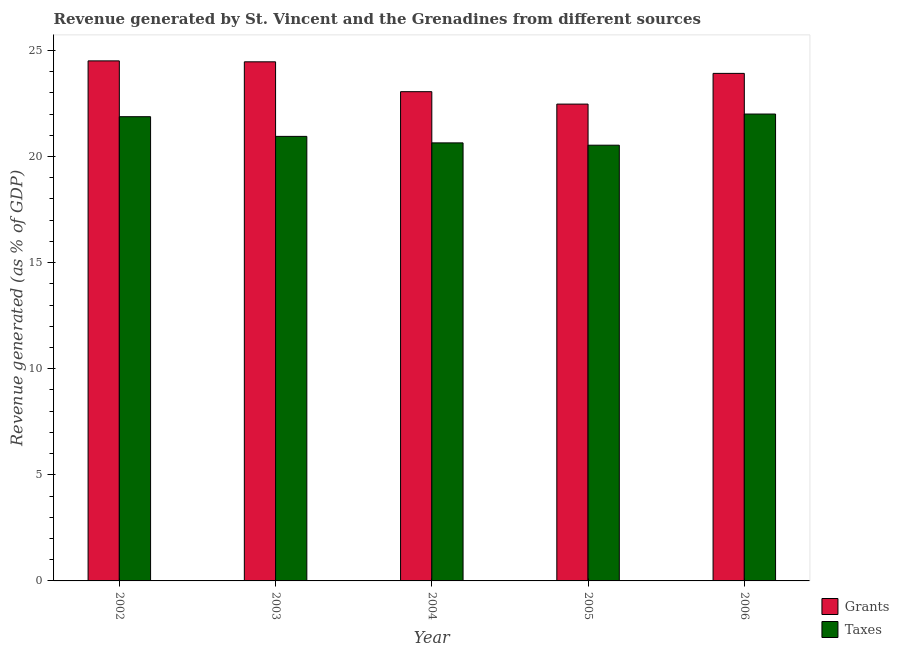How many groups of bars are there?
Provide a short and direct response. 5. What is the label of the 5th group of bars from the left?
Ensure brevity in your answer.  2006. In how many cases, is the number of bars for a given year not equal to the number of legend labels?
Your answer should be very brief. 0. What is the revenue generated by taxes in 2006?
Offer a very short reply. 22. Across all years, what is the maximum revenue generated by taxes?
Give a very brief answer. 22. Across all years, what is the minimum revenue generated by grants?
Offer a terse response. 22.47. In which year was the revenue generated by grants maximum?
Your response must be concise. 2002. What is the total revenue generated by grants in the graph?
Provide a short and direct response. 118.4. What is the difference between the revenue generated by grants in 2002 and that in 2004?
Your response must be concise. 1.45. What is the difference between the revenue generated by taxes in 2003 and the revenue generated by grants in 2005?
Offer a very short reply. 0.42. What is the average revenue generated by taxes per year?
Your answer should be compact. 21.2. In how many years, is the revenue generated by grants greater than 17 %?
Provide a succinct answer. 5. What is the ratio of the revenue generated by taxes in 2005 to that in 2006?
Keep it short and to the point. 0.93. Is the revenue generated by taxes in 2003 less than that in 2005?
Your answer should be very brief. No. What is the difference between the highest and the second highest revenue generated by taxes?
Your answer should be very brief. 0.12. What is the difference between the highest and the lowest revenue generated by grants?
Provide a succinct answer. 2.04. Is the sum of the revenue generated by grants in 2004 and 2005 greater than the maximum revenue generated by taxes across all years?
Offer a terse response. Yes. What does the 2nd bar from the left in 2005 represents?
Provide a succinct answer. Taxes. What does the 1st bar from the right in 2002 represents?
Offer a terse response. Taxes. Are all the bars in the graph horizontal?
Provide a short and direct response. No. What is the difference between two consecutive major ticks on the Y-axis?
Your response must be concise. 5. Are the values on the major ticks of Y-axis written in scientific E-notation?
Provide a short and direct response. No. Does the graph contain any zero values?
Your answer should be very brief. No. Does the graph contain grids?
Give a very brief answer. No. What is the title of the graph?
Your answer should be very brief. Revenue generated by St. Vincent and the Grenadines from different sources. What is the label or title of the X-axis?
Ensure brevity in your answer.  Year. What is the label or title of the Y-axis?
Provide a succinct answer. Revenue generated (as % of GDP). What is the Revenue generated (as % of GDP) of Grants in 2002?
Your answer should be compact. 24.51. What is the Revenue generated (as % of GDP) in Taxes in 2002?
Keep it short and to the point. 21.88. What is the Revenue generated (as % of GDP) of Grants in 2003?
Make the answer very short. 24.46. What is the Revenue generated (as % of GDP) of Taxes in 2003?
Offer a very short reply. 20.95. What is the Revenue generated (as % of GDP) of Grants in 2004?
Provide a succinct answer. 23.05. What is the Revenue generated (as % of GDP) of Taxes in 2004?
Offer a terse response. 20.64. What is the Revenue generated (as % of GDP) in Grants in 2005?
Your answer should be very brief. 22.47. What is the Revenue generated (as % of GDP) of Taxes in 2005?
Your answer should be compact. 20.53. What is the Revenue generated (as % of GDP) in Grants in 2006?
Offer a very short reply. 23.92. What is the Revenue generated (as % of GDP) in Taxes in 2006?
Offer a very short reply. 22. Across all years, what is the maximum Revenue generated (as % of GDP) of Grants?
Give a very brief answer. 24.51. Across all years, what is the maximum Revenue generated (as % of GDP) of Taxes?
Your response must be concise. 22. Across all years, what is the minimum Revenue generated (as % of GDP) of Grants?
Your answer should be very brief. 22.47. Across all years, what is the minimum Revenue generated (as % of GDP) in Taxes?
Your answer should be very brief. 20.53. What is the total Revenue generated (as % of GDP) of Grants in the graph?
Offer a very short reply. 118.4. What is the total Revenue generated (as % of GDP) of Taxes in the graph?
Ensure brevity in your answer.  106. What is the difference between the Revenue generated (as % of GDP) of Grants in 2002 and that in 2003?
Your answer should be compact. 0.04. What is the difference between the Revenue generated (as % of GDP) in Taxes in 2002 and that in 2003?
Give a very brief answer. 0.93. What is the difference between the Revenue generated (as % of GDP) in Grants in 2002 and that in 2004?
Provide a succinct answer. 1.45. What is the difference between the Revenue generated (as % of GDP) of Taxes in 2002 and that in 2004?
Your response must be concise. 1.23. What is the difference between the Revenue generated (as % of GDP) of Grants in 2002 and that in 2005?
Your response must be concise. 2.04. What is the difference between the Revenue generated (as % of GDP) of Taxes in 2002 and that in 2005?
Your answer should be very brief. 1.34. What is the difference between the Revenue generated (as % of GDP) in Grants in 2002 and that in 2006?
Offer a terse response. 0.59. What is the difference between the Revenue generated (as % of GDP) of Taxes in 2002 and that in 2006?
Your response must be concise. -0.12. What is the difference between the Revenue generated (as % of GDP) of Grants in 2003 and that in 2004?
Your response must be concise. 1.41. What is the difference between the Revenue generated (as % of GDP) in Taxes in 2003 and that in 2004?
Offer a terse response. 0.31. What is the difference between the Revenue generated (as % of GDP) of Grants in 2003 and that in 2005?
Your response must be concise. 1.99. What is the difference between the Revenue generated (as % of GDP) in Taxes in 2003 and that in 2005?
Your response must be concise. 0.42. What is the difference between the Revenue generated (as % of GDP) in Grants in 2003 and that in 2006?
Ensure brevity in your answer.  0.54. What is the difference between the Revenue generated (as % of GDP) of Taxes in 2003 and that in 2006?
Make the answer very short. -1.05. What is the difference between the Revenue generated (as % of GDP) in Grants in 2004 and that in 2005?
Your answer should be compact. 0.58. What is the difference between the Revenue generated (as % of GDP) in Taxes in 2004 and that in 2005?
Ensure brevity in your answer.  0.11. What is the difference between the Revenue generated (as % of GDP) in Grants in 2004 and that in 2006?
Offer a terse response. -0.86. What is the difference between the Revenue generated (as % of GDP) in Taxes in 2004 and that in 2006?
Provide a succinct answer. -1.36. What is the difference between the Revenue generated (as % of GDP) of Grants in 2005 and that in 2006?
Your answer should be compact. -1.45. What is the difference between the Revenue generated (as % of GDP) in Taxes in 2005 and that in 2006?
Offer a very short reply. -1.47. What is the difference between the Revenue generated (as % of GDP) in Grants in 2002 and the Revenue generated (as % of GDP) in Taxes in 2003?
Your response must be concise. 3.56. What is the difference between the Revenue generated (as % of GDP) in Grants in 2002 and the Revenue generated (as % of GDP) in Taxes in 2004?
Your answer should be compact. 3.86. What is the difference between the Revenue generated (as % of GDP) of Grants in 2002 and the Revenue generated (as % of GDP) of Taxes in 2005?
Your response must be concise. 3.97. What is the difference between the Revenue generated (as % of GDP) in Grants in 2002 and the Revenue generated (as % of GDP) in Taxes in 2006?
Provide a succinct answer. 2.51. What is the difference between the Revenue generated (as % of GDP) in Grants in 2003 and the Revenue generated (as % of GDP) in Taxes in 2004?
Your answer should be compact. 3.82. What is the difference between the Revenue generated (as % of GDP) in Grants in 2003 and the Revenue generated (as % of GDP) in Taxes in 2005?
Offer a very short reply. 3.93. What is the difference between the Revenue generated (as % of GDP) in Grants in 2003 and the Revenue generated (as % of GDP) in Taxes in 2006?
Provide a succinct answer. 2.46. What is the difference between the Revenue generated (as % of GDP) of Grants in 2004 and the Revenue generated (as % of GDP) of Taxes in 2005?
Provide a short and direct response. 2.52. What is the difference between the Revenue generated (as % of GDP) in Grants in 2004 and the Revenue generated (as % of GDP) in Taxes in 2006?
Give a very brief answer. 1.05. What is the difference between the Revenue generated (as % of GDP) of Grants in 2005 and the Revenue generated (as % of GDP) of Taxes in 2006?
Ensure brevity in your answer.  0.47. What is the average Revenue generated (as % of GDP) in Grants per year?
Provide a short and direct response. 23.68. What is the average Revenue generated (as % of GDP) in Taxes per year?
Give a very brief answer. 21.2. In the year 2002, what is the difference between the Revenue generated (as % of GDP) of Grants and Revenue generated (as % of GDP) of Taxes?
Offer a very short reply. 2.63. In the year 2003, what is the difference between the Revenue generated (as % of GDP) of Grants and Revenue generated (as % of GDP) of Taxes?
Your answer should be compact. 3.51. In the year 2004, what is the difference between the Revenue generated (as % of GDP) of Grants and Revenue generated (as % of GDP) of Taxes?
Your answer should be compact. 2.41. In the year 2005, what is the difference between the Revenue generated (as % of GDP) in Grants and Revenue generated (as % of GDP) in Taxes?
Offer a terse response. 1.94. In the year 2006, what is the difference between the Revenue generated (as % of GDP) in Grants and Revenue generated (as % of GDP) in Taxes?
Your answer should be compact. 1.92. What is the ratio of the Revenue generated (as % of GDP) in Grants in 2002 to that in 2003?
Make the answer very short. 1. What is the ratio of the Revenue generated (as % of GDP) in Taxes in 2002 to that in 2003?
Your response must be concise. 1.04. What is the ratio of the Revenue generated (as % of GDP) of Grants in 2002 to that in 2004?
Offer a terse response. 1.06. What is the ratio of the Revenue generated (as % of GDP) of Taxes in 2002 to that in 2004?
Your answer should be compact. 1.06. What is the ratio of the Revenue generated (as % of GDP) in Grants in 2002 to that in 2005?
Offer a terse response. 1.09. What is the ratio of the Revenue generated (as % of GDP) of Taxes in 2002 to that in 2005?
Provide a succinct answer. 1.07. What is the ratio of the Revenue generated (as % of GDP) of Grants in 2002 to that in 2006?
Provide a short and direct response. 1.02. What is the ratio of the Revenue generated (as % of GDP) in Grants in 2003 to that in 2004?
Your answer should be very brief. 1.06. What is the ratio of the Revenue generated (as % of GDP) of Taxes in 2003 to that in 2004?
Give a very brief answer. 1.01. What is the ratio of the Revenue generated (as % of GDP) in Grants in 2003 to that in 2005?
Offer a very short reply. 1.09. What is the ratio of the Revenue generated (as % of GDP) in Taxes in 2003 to that in 2005?
Your response must be concise. 1.02. What is the ratio of the Revenue generated (as % of GDP) in Grants in 2003 to that in 2006?
Provide a succinct answer. 1.02. What is the ratio of the Revenue generated (as % of GDP) in Taxes in 2003 to that in 2006?
Give a very brief answer. 0.95. What is the ratio of the Revenue generated (as % of GDP) of Taxes in 2004 to that in 2005?
Provide a succinct answer. 1.01. What is the ratio of the Revenue generated (as % of GDP) of Grants in 2004 to that in 2006?
Make the answer very short. 0.96. What is the ratio of the Revenue generated (as % of GDP) in Taxes in 2004 to that in 2006?
Provide a short and direct response. 0.94. What is the ratio of the Revenue generated (as % of GDP) in Grants in 2005 to that in 2006?
Ensure brevity in your answer.  0.94. What is the difference between the highest and the second highest Revenue generated (as % of GDP) of Grants?
Keep it short and to the point. 0.04. What is the difference between the highest and the second highest Revenue generated (as % of GDP) of Taxes?
Your response must be concise. 0.12. What is the difference between the highest and the lowest Revenue generated (as % of GDP) in Grants?
Give a very brief answer. 2.04. What is the difference between the highest and the lowest Revenue generated (as % of GDP) of Taxes?
Keep it short and to the point. 1.47. 